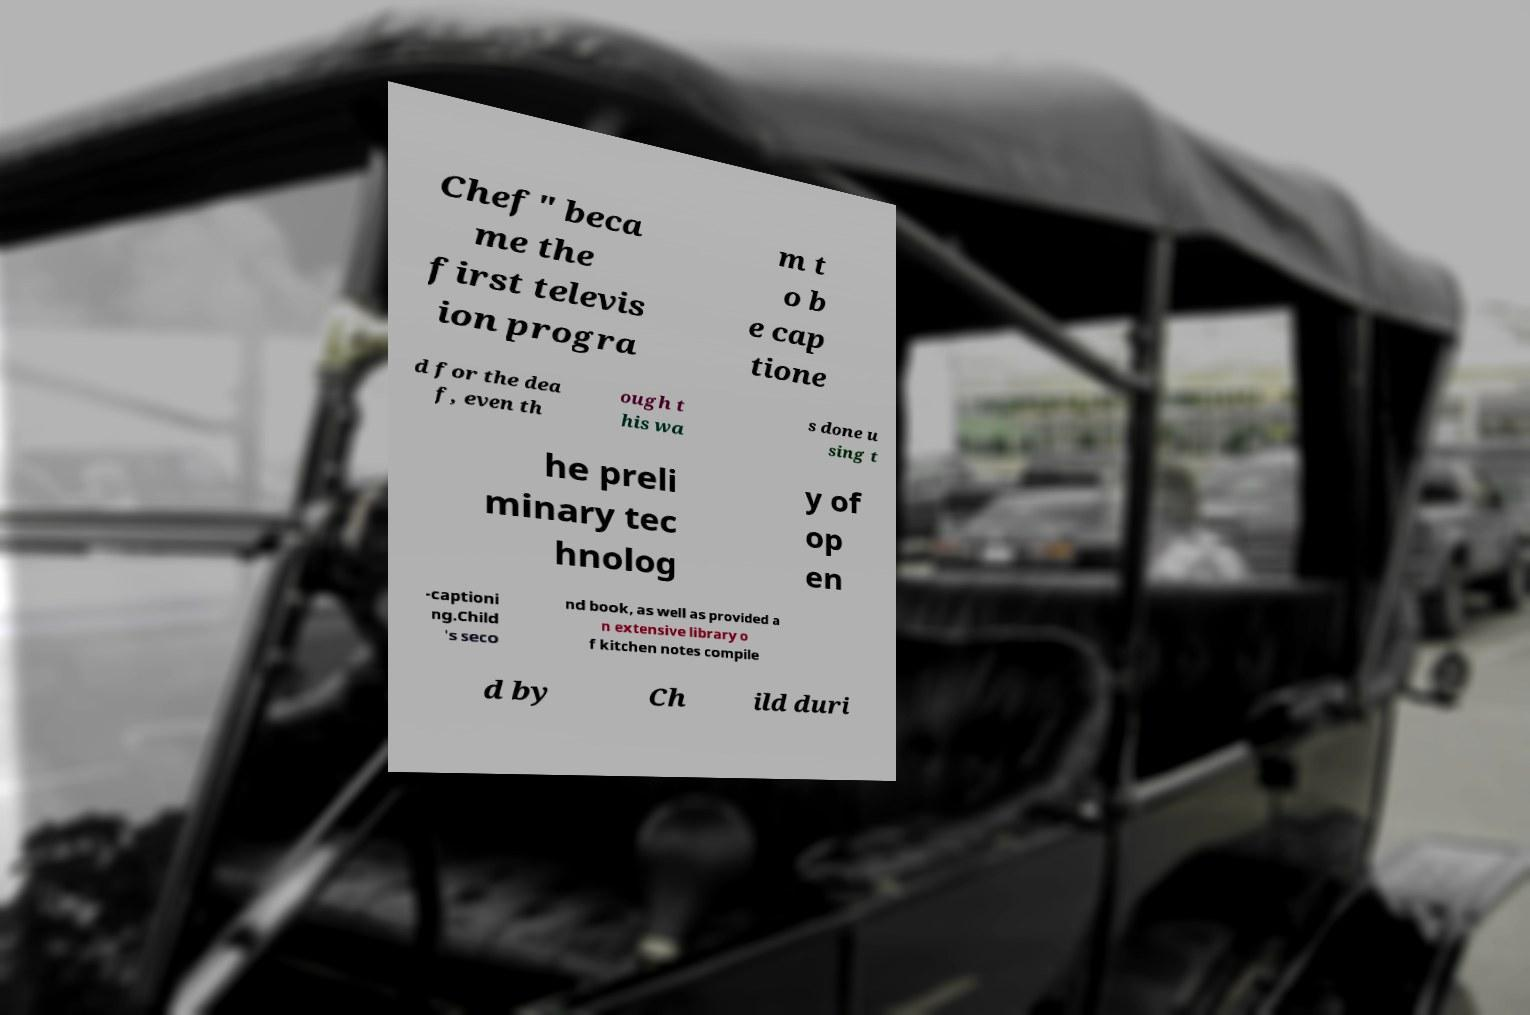Could you assist in decoding the text presented in this image and type it out clearly? Chef" beca me the first televis ion progra m t o b e cap tione d for the dea f, even th ough t his wa s done u sing t he preli minary tec hnolog y of op en -captioni ng.Child 's seco nd book, as well as provided a n extensive library o f kitchen notes compile d by Ch ild duri 